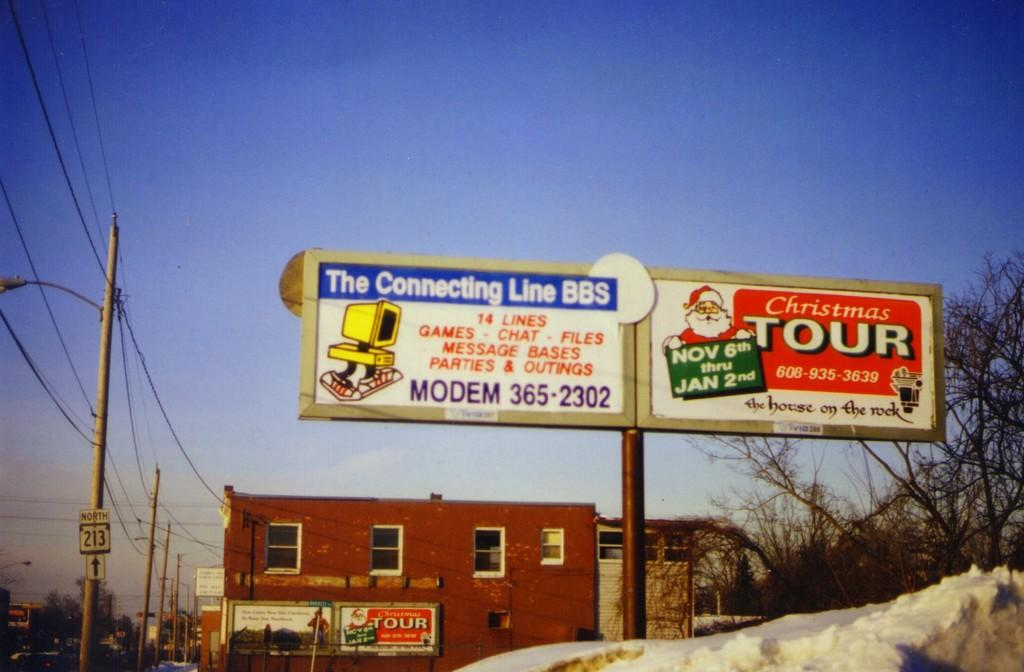<image>
Relay a brief, clear account of the picture shown. TWO CONNECTED SIGNBOARDS, ONE IS FOR COMPUTERS AND THE OTHER IS FOR A CHRISTMAS TOUR. 